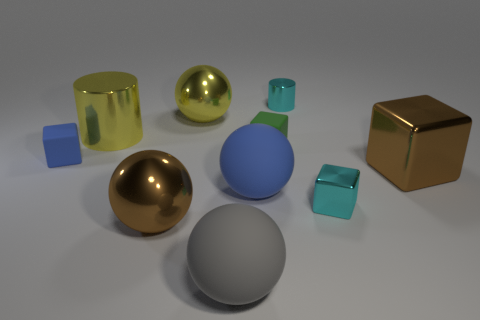Subtract all spheres. How many objects are left? 6 Subtract all blue cylinders. Subtract all large brown cubes. How many objects are left? 9 Add 6 tiny objects. How many tiny objects are left? 10 Add 1 big brown objects. How many big brown objects exist? 3 Subtract 1 cyan blocks. How many objects are left? 9 